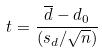Convert formula to latex. <formula><loc_0><loc_0><loc_500><loc_500>t = \frac { \overline { d } - d _ { 0 } } { ( s _ { d } / \sqrt { n } ) }</formula> 